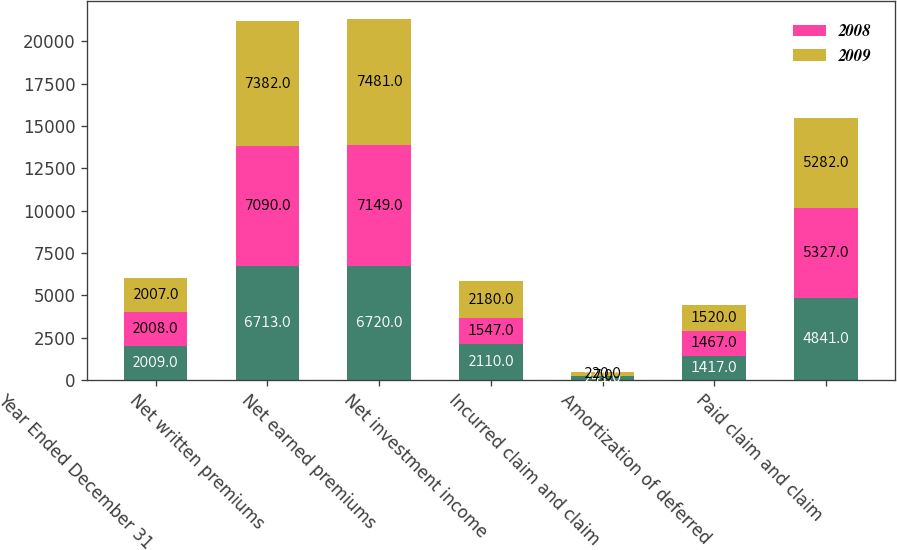Convert chart to OTSL. <chart><loc_0><loc_0><loc_500><loc_500><stacked_bar_chart><ecel><fcel>Year Ended December 31<fcel>Net written premiums<fcel>Net earned premiums<fcel>Net investment income<fcel>Incurred claim and claim<fcel>Amortization of deferred<fcel>Paid claim and claim<nl><fcel>nan<fcel>2009<fcel>6713<fcel>6720<fcel>2110<fcel>241<fcel>1417<fcel>4841<nl><fcel>2008<fcel>2008<fcel>7090<fcel>7149<fcel>1547<fcel>7<fcel>1467<fcel>5327<nl><fcel>2009<fcel>2007<fcel>7382<fcel>7481<fcel>2180<fcel>220<fcel>1520<fcel>5282<nl></chart> 